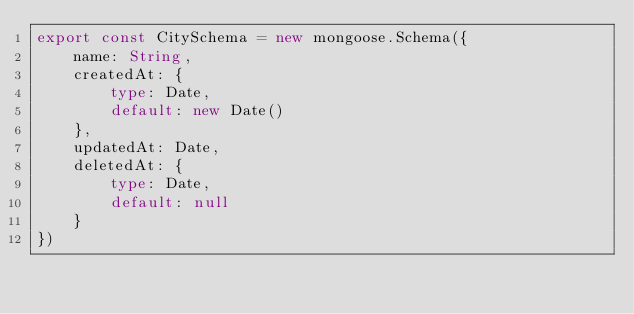<code> <loc_0><loc_0><loc_500><loc_500><_TypeScript_>export const CitySchema = new mongoose.Schema({
    name: String,
    createdAt: {
        type: Date,
        default: new Date()
    },
    updatedAt: Date,
    deletedAt: {
        type: Date,
        default: null
    }
})</code> 